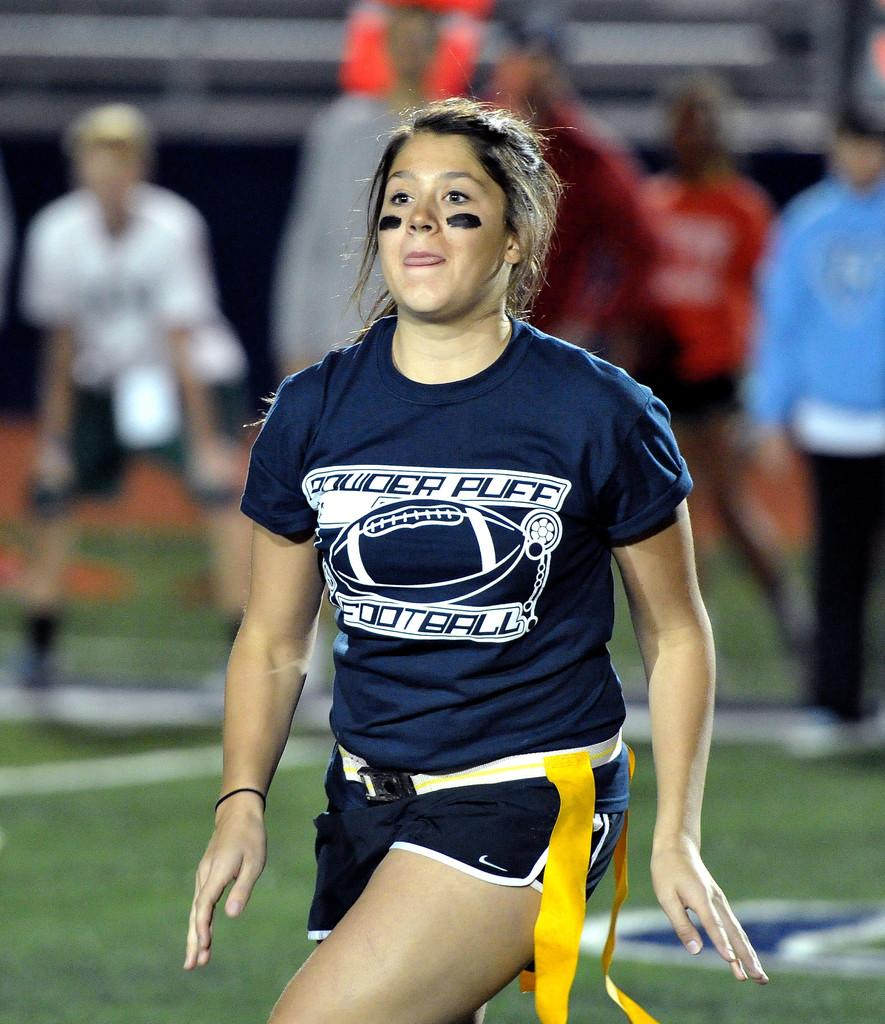<image>
Provide a brief description of the given image. A female player on the Powder Puff football team in uniform on the playing field near a sideline where people stand.. 